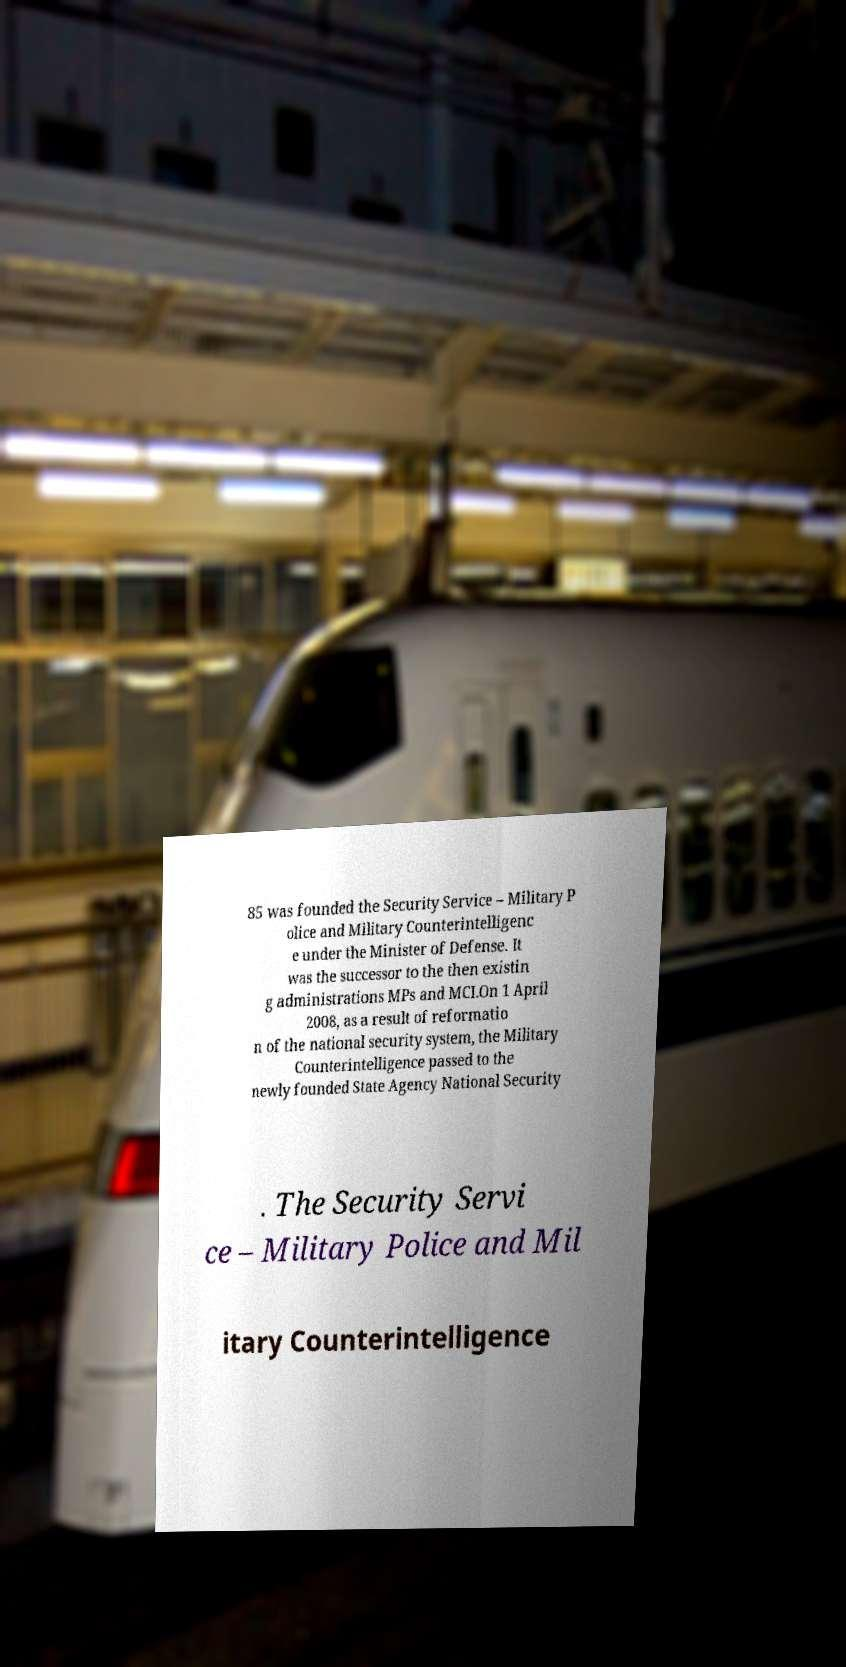Can you read and provide the text displayed in the image?This photo seems to have some interesting text. Can you extract and type it out for me? 85 was founded the Security Service – Military P olice and Military Counterintelligenc e under the Minister of Defense. It was the successor to the then existin g administrations MPs and MCI.On 1 April 2008, as a result of reformatio n of the national security system, the Military Counterintelligence passed to the newly founded State Agency National Security . The Security Servi ce – Military Police and Mil itary Counterintelligence 